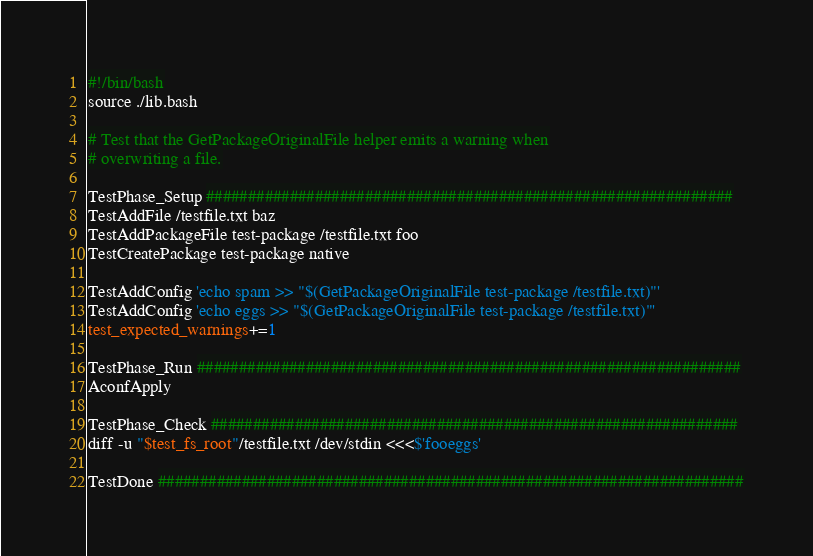<code> <loc_0><loc_0><loc_500><loc_500><_Bash_>#!/bin/bash
source ./lib.bash

# Test that the GetPackageOriginalFile helper emits a warning when
# overwriting a file.

TestPhase_Setup ###############################################################
TestAddFile /testfile.txt baz
TestAddPackageFile test-package /testfile.txt foo
TestCreatePackage test-package native

TestAddConfig 'echo spam >> "$(GetPackageOriginalFile test-package /testfile.txt)"'
TestAddConfig 'echo eggs >> "$(GetPackageOriginalFile test-package /testfile.txt)"'
test_expected_warnings+=1

TestPhase_Run #################################################################
AconfApply

TestPhase_Check ###############################################################
diff -u "$test_fs_root"/testfile.txt /dev/stdin <<<$'fooeggs'

TestDone ######################################################################
</code> 